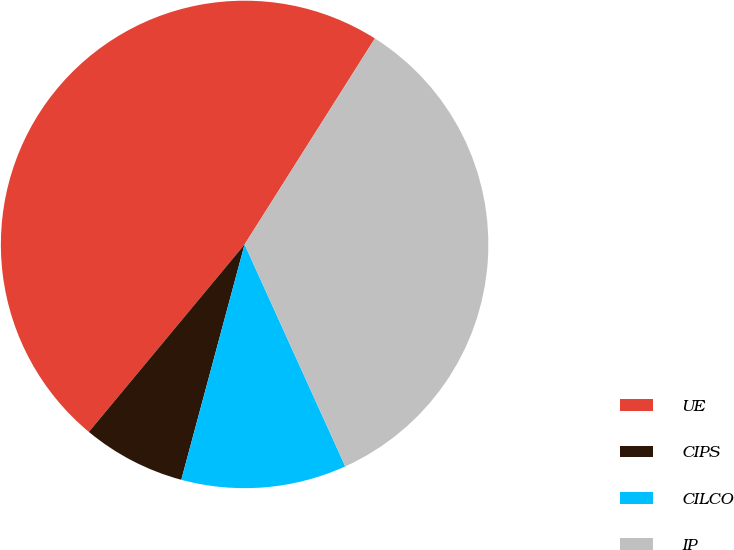<chart> <loc_0><loc_0><loc_500><loc_500><pie_chart><fcel>UE<fcel>CIPS<fcel>CILCO<fcel>IP<nl><fcel>47.95%<fcel>6.85%<fcel>10.96%<fcel>34.25%<nl></chart> 